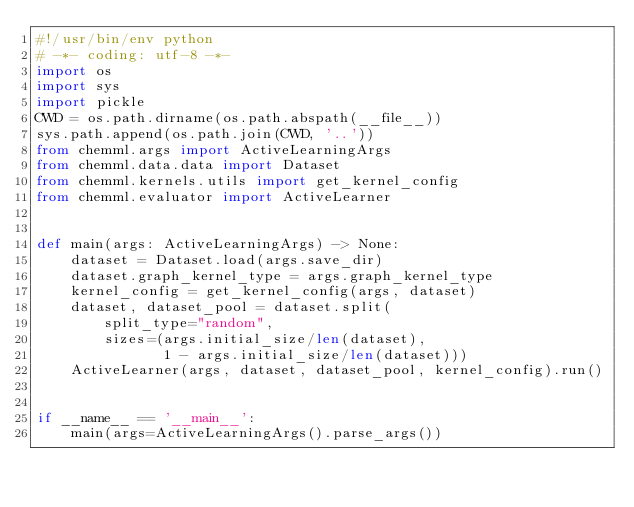<code> <loc_0><loc_0><loc_500><loc_500><_Python_>#!/usr/bin/env python
# -*- coding: utf-8 -*-
import os
import sys
import pickle
CWD = os.path.dirname(os.path.abspath(__file__))
sys.path.append(os.path.join(CWD, '..'))
from chemml.args import ActiveLearningArgs
from chemml.data.data import Dataset
from chemml.kernels.utils import get_kernel_config
from chemml.evaluator import ActiveLearner


def main(args: ActiveLearningArgs) -> None:
    dataset = Dataset.load(args.save_dir)
    dataset.graph_kernel_type = args.graph_kernel_type
    kernel_config = get_kernel_config(args, dataset)
    dataset, dataset_pool = dataset.split(
        split_type="random",
        sizes=(args.initial_size/len(dataset),
               1 - args.initial_size/len(dataset)))
    ActiveLearner(args, dataset, dataset_pool, kernel_config).run()


if __name__ == '__main__':
    main(args=ActiveLearningArgs().parse_args())
</code> 